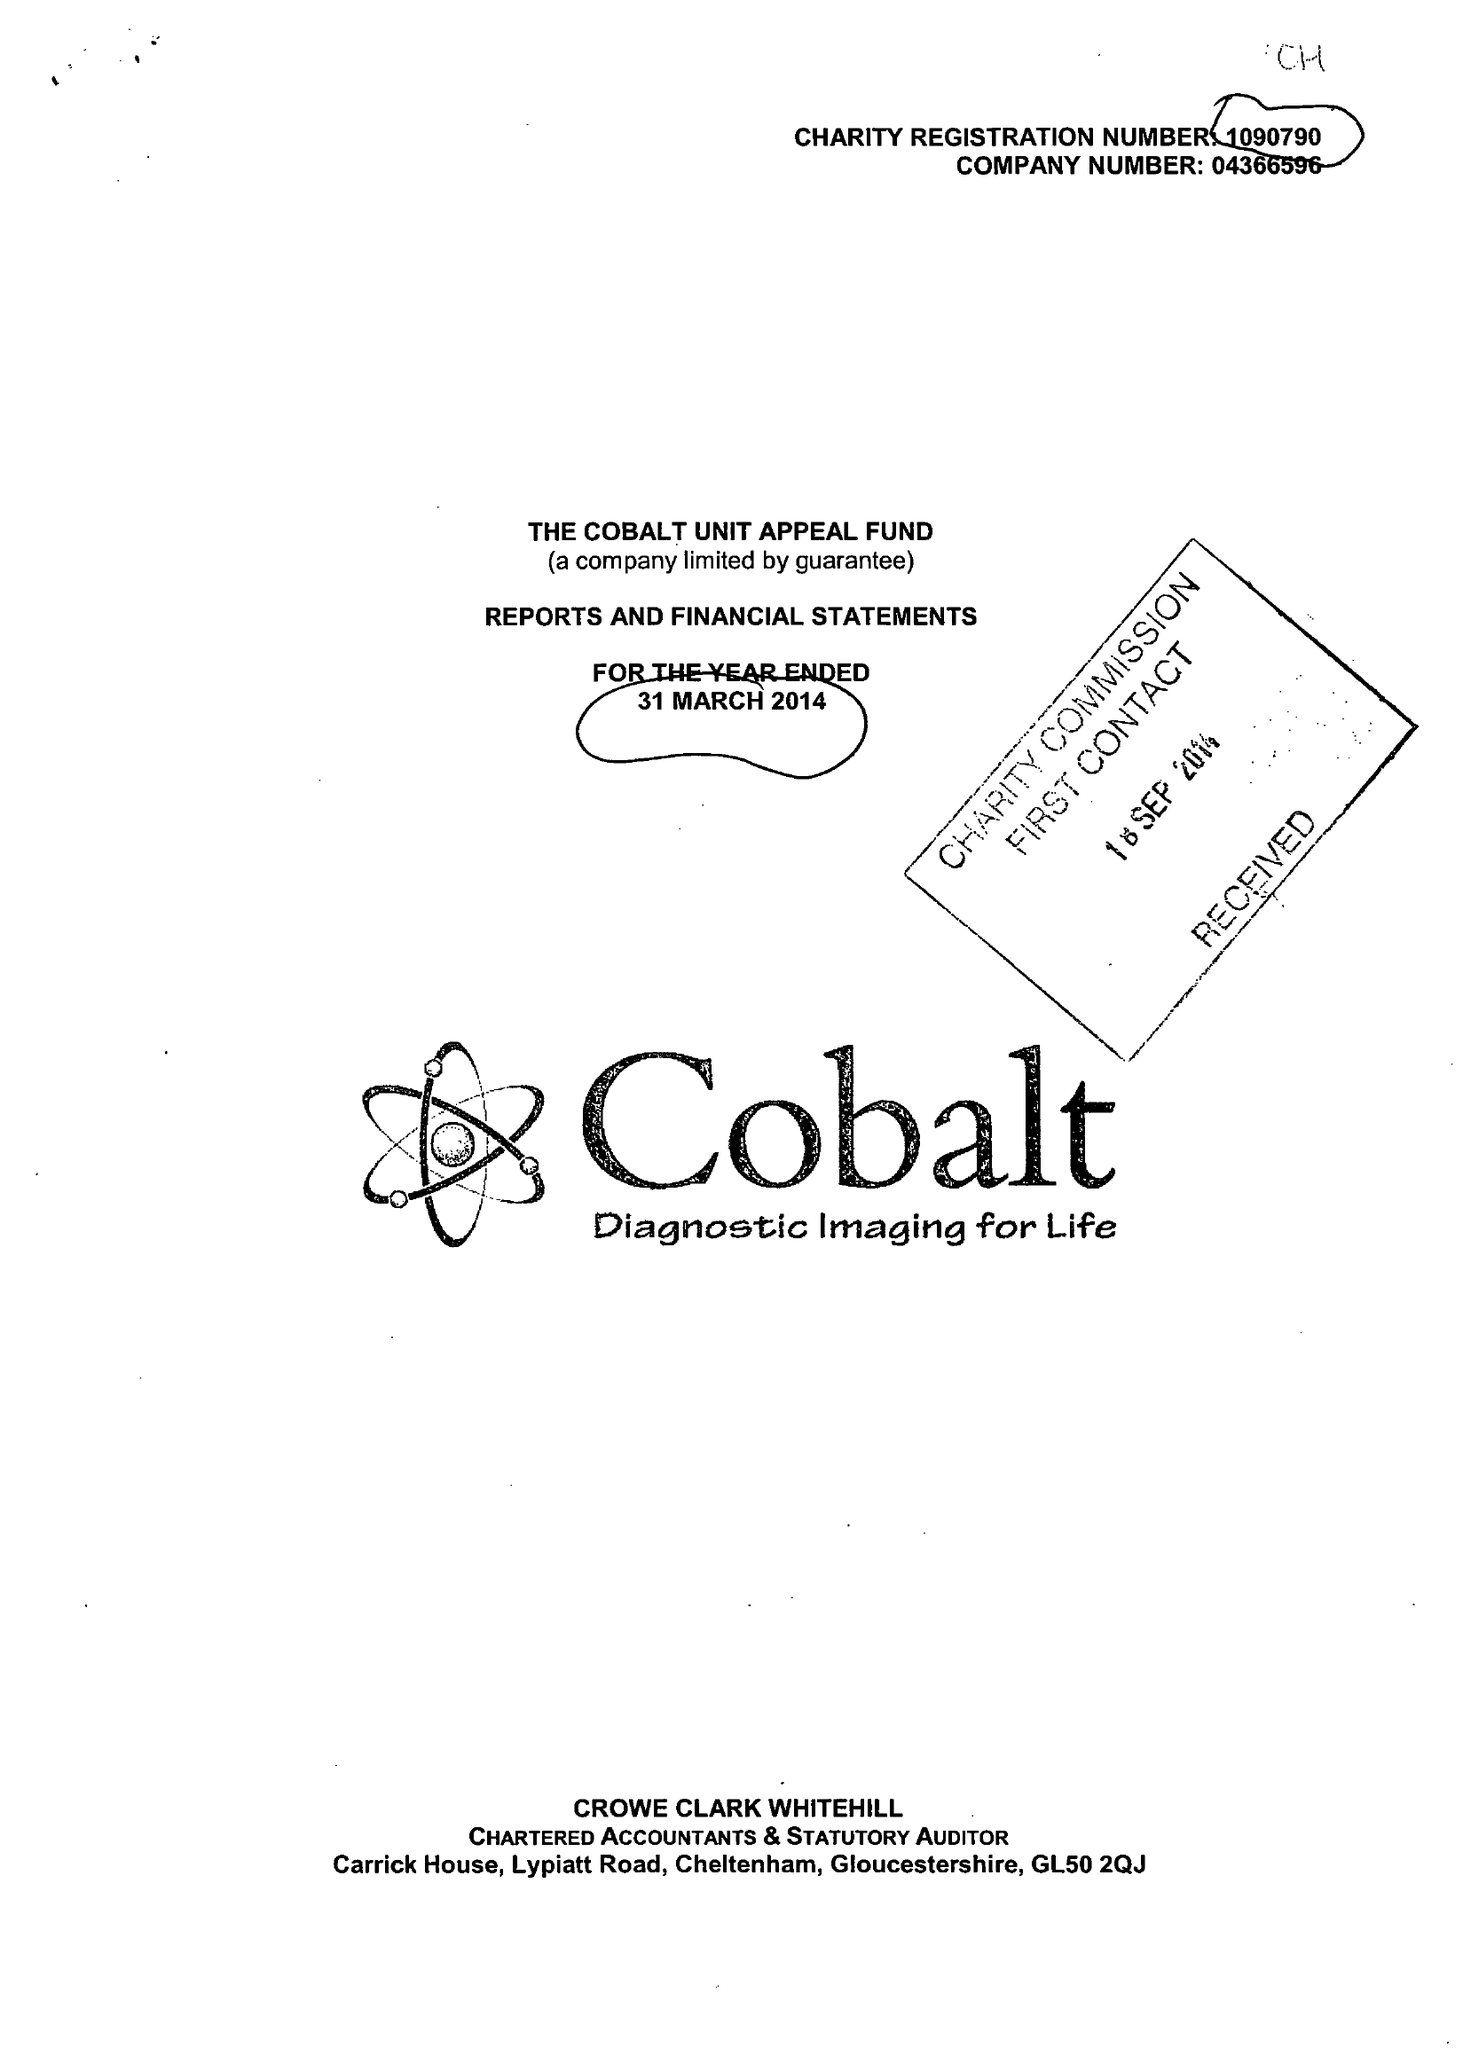What is the value for the address__post_town?
Answer the question using a single word or phrase. CHELTENHAM 